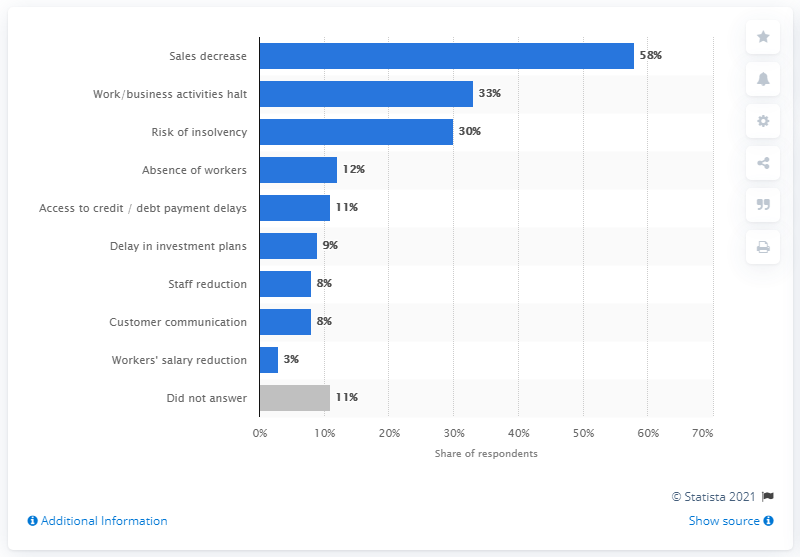Mention a couple of crucial points in this snapshot. According to a survey of Chilean company executives conducted in March 2020, 58% predicted a decrease in sales due to the COVID-19 pandemic. 